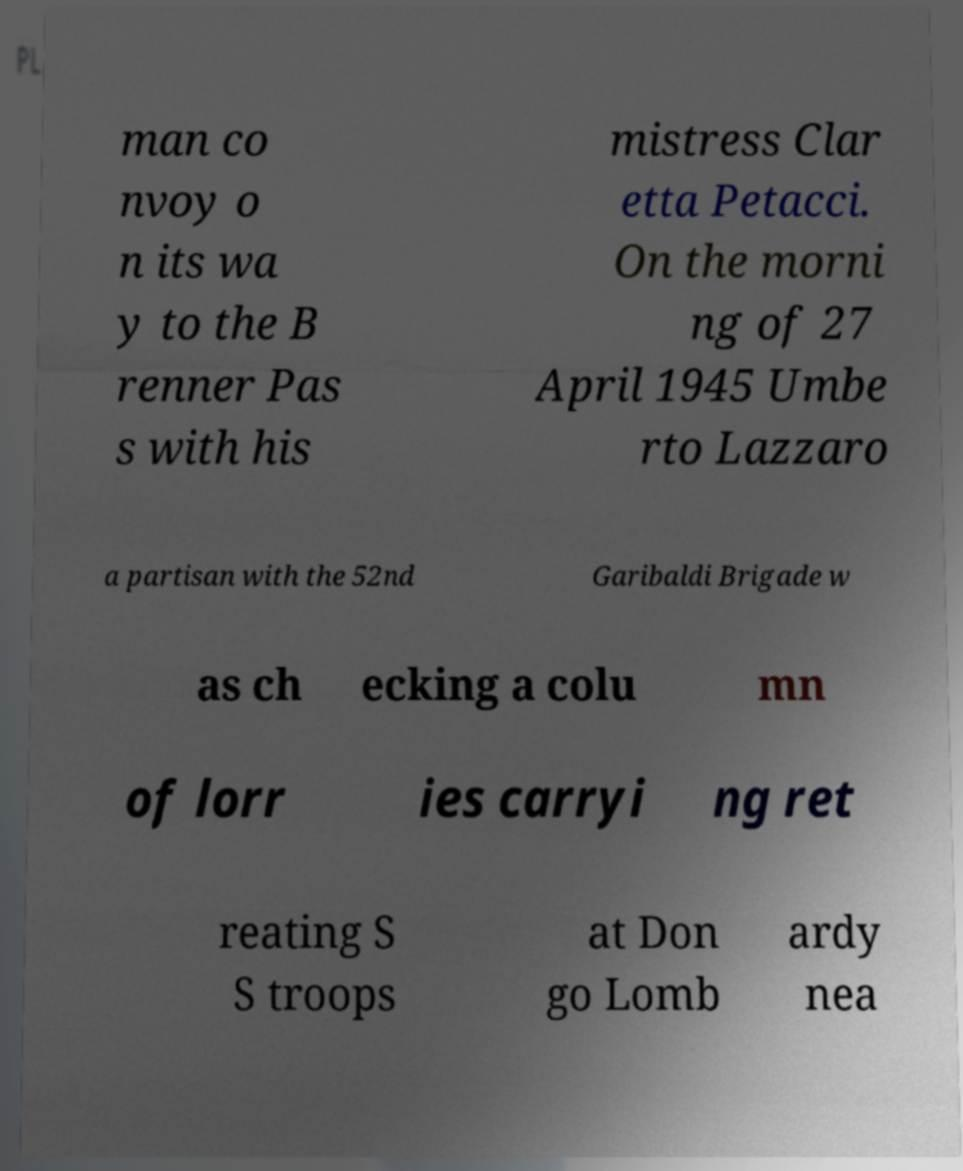What messages or text are displayed in this image? I need them in a readable, typed format. man co nvoy o n its wa y to the B renner Pas s with his mistress Clar etta Petacci. On the morni ng of 27 April 1945 Umbe rto Lazzaro a partisan with the 52nd Garibaldi Brigade w as ch ecking a colu mn of lorr ies carryi ng ret reating S S troops at Don go Lomb ardy nea 